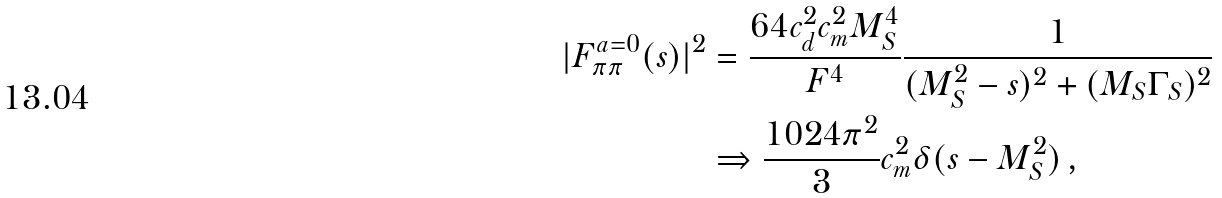<formula> <loc_0><loc_0><loc_500><loc_500>| F _ { \pi \pi } ^ { a = 0 } ( s ) | ^ { 2 } & = \frac { 6 4 c _ { d } ^ { 2 } c _ { m } ^ { 2 } M _ { S } ^ { 4 } } { F ^ { 4 } } \frac { 1 } { ( M _ { S } ^ { 2 } - s ) ^ { 2 } + ( M _ { S } \Gamma _ { S } ) ^ { 2 } } \\ & \Rightarrow \frac { 1 0 2 4 \pi ^ { 2 } } { 3 } c _ { m } ^ { 2 } \delta ( s - M _ { S } ^ { 2 } ) \, ,</formula> 